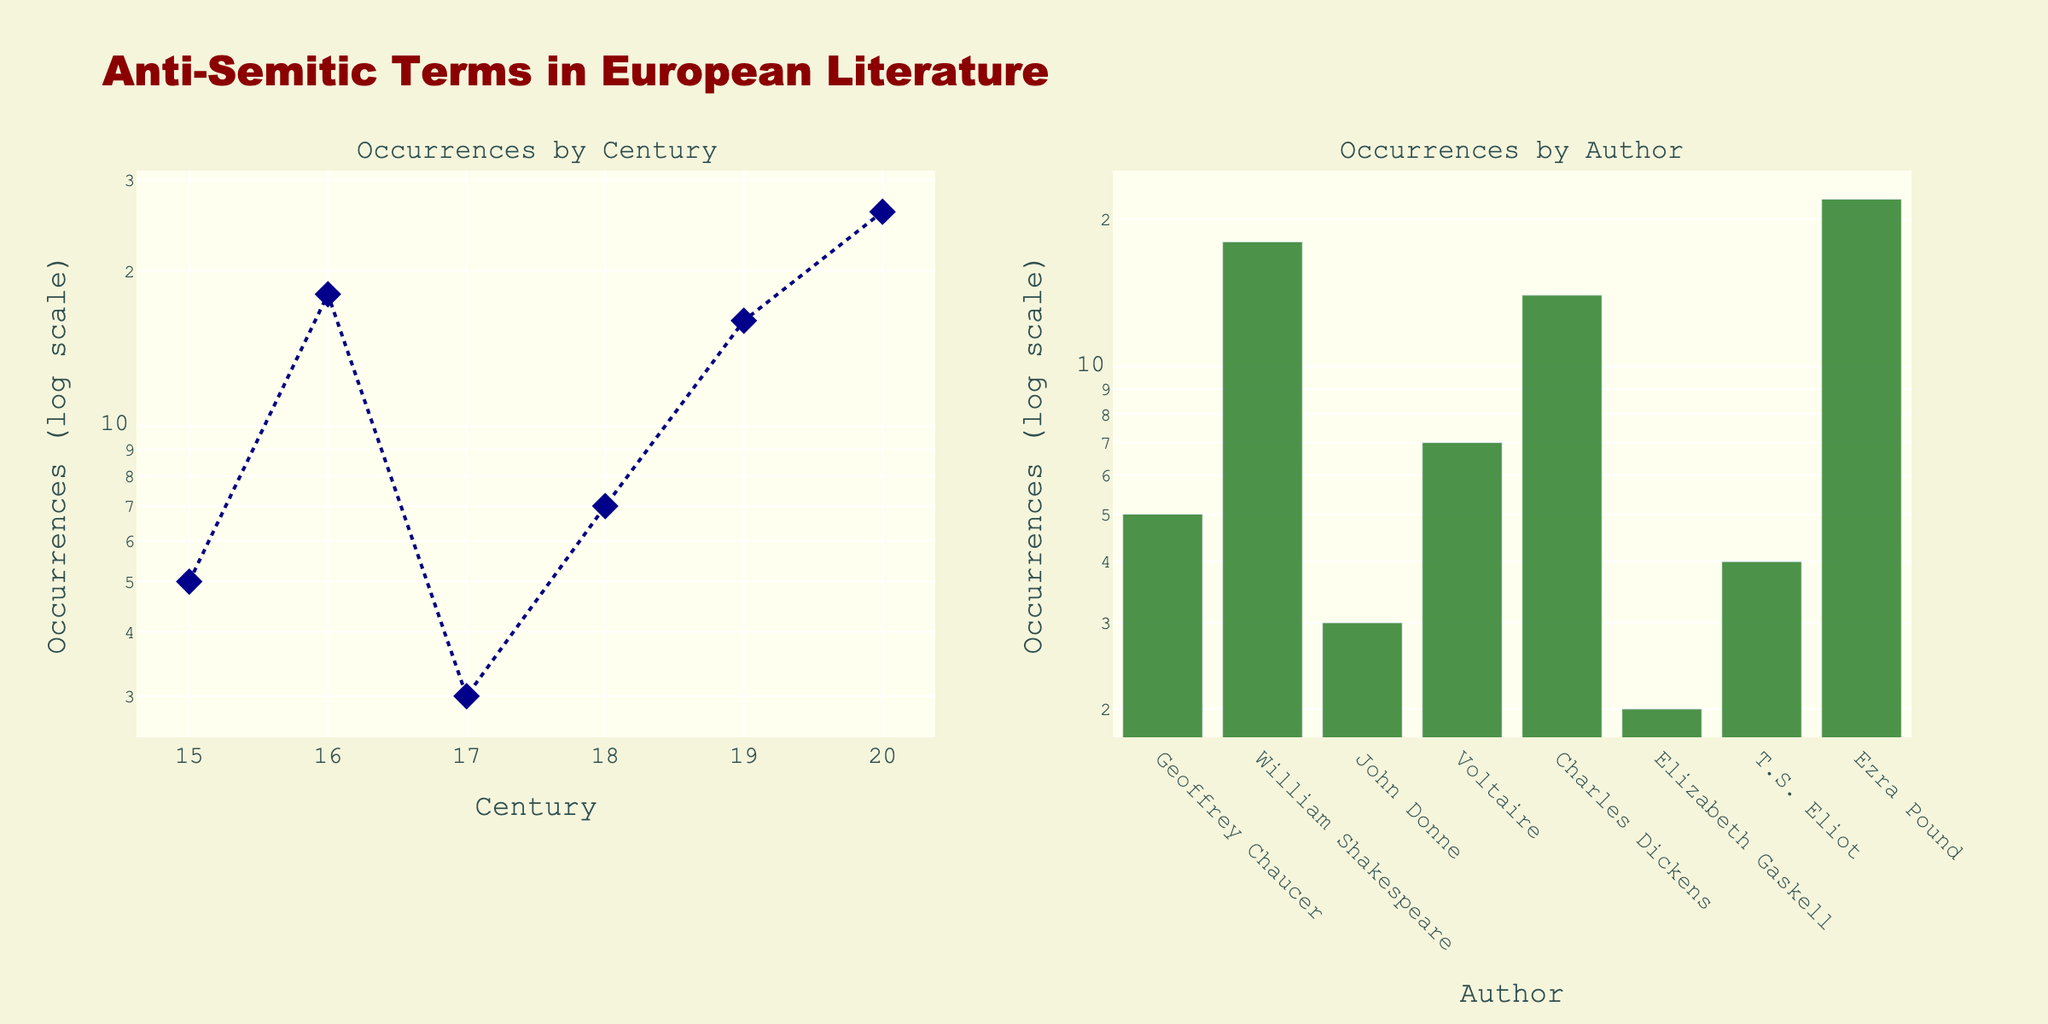what is the title of the figure? The title of the figure is located at the top of the plots. It provides an overarching description of what is being visualized.
Answer: Anti-Semitic Terms in European Literature how many data points are plotted in the Century subplot? Count the number of markers present in the line plot on the left side of the figure. Each marker represents a data point corresponding to a sum of occurrences for each century.
Answer: 6 how many authors are represented in the Author subplot? Look at the x-axis labels of the bar plot on the right side of the figure. Each label corresponds to an author.
Answer: 8 which century has the highest number of occurrences of anti-semitic terms? Identify which marker in the line plot on the left side of the figure is highest on the y-axis. The x-axis label of this marker provides the century.
Answer: 20th century what's the total number of anti-semitic terms occurrences in the 19th century? Look at the sum of occurrences for the 19th century in the line plot and read the corresponding y-axis value.
Answer: 16 which author has the highest number of occurrences of anti-semitic terms? Identify the tallest bar in the bar plot on the right side of the figure, corresponding to the author with the highest number of occurrences.
Answer: Ezra Pound how does the frequency in the 18th century compare to the 19th century? Compare the height of the markers for the 18th and 19th centuries in the line plot. Determine which one is taller.
Answer: Less than (7 vs. 16) which century has a similar number of occurrences to that of Geoffrey Chaucer's work? Find the point in the line plot where the number of occurrences is close to the occurrence value of Geoffrey Chaucer's work in the bar plot, then match the century.
Answer: 20th century 